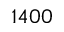<formula> <loc_0><loc_0><loc_500><loc_500>1 4 0 0</formula> 